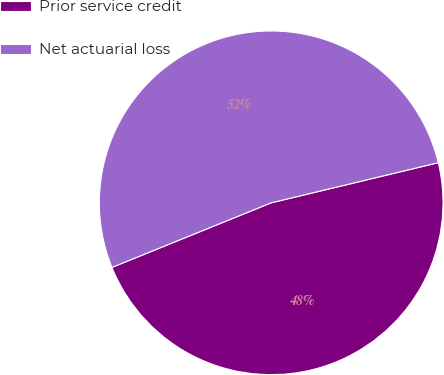<chart> <loc_0><loc_0><loc_500><loc_500><pie_chart><fcel>Prior service credit<fcel>Net actuarial loss<nl><fcel>47.62%<fcel>52.38%<nl></chart> 